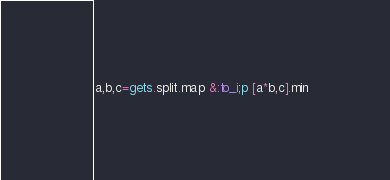Convert code to text. <code><loc_0><loc_0><loc_500><loc_500><_Ruby_>a,b,c=gets.split.map &:to_i;p [a*b,c].min</code> 